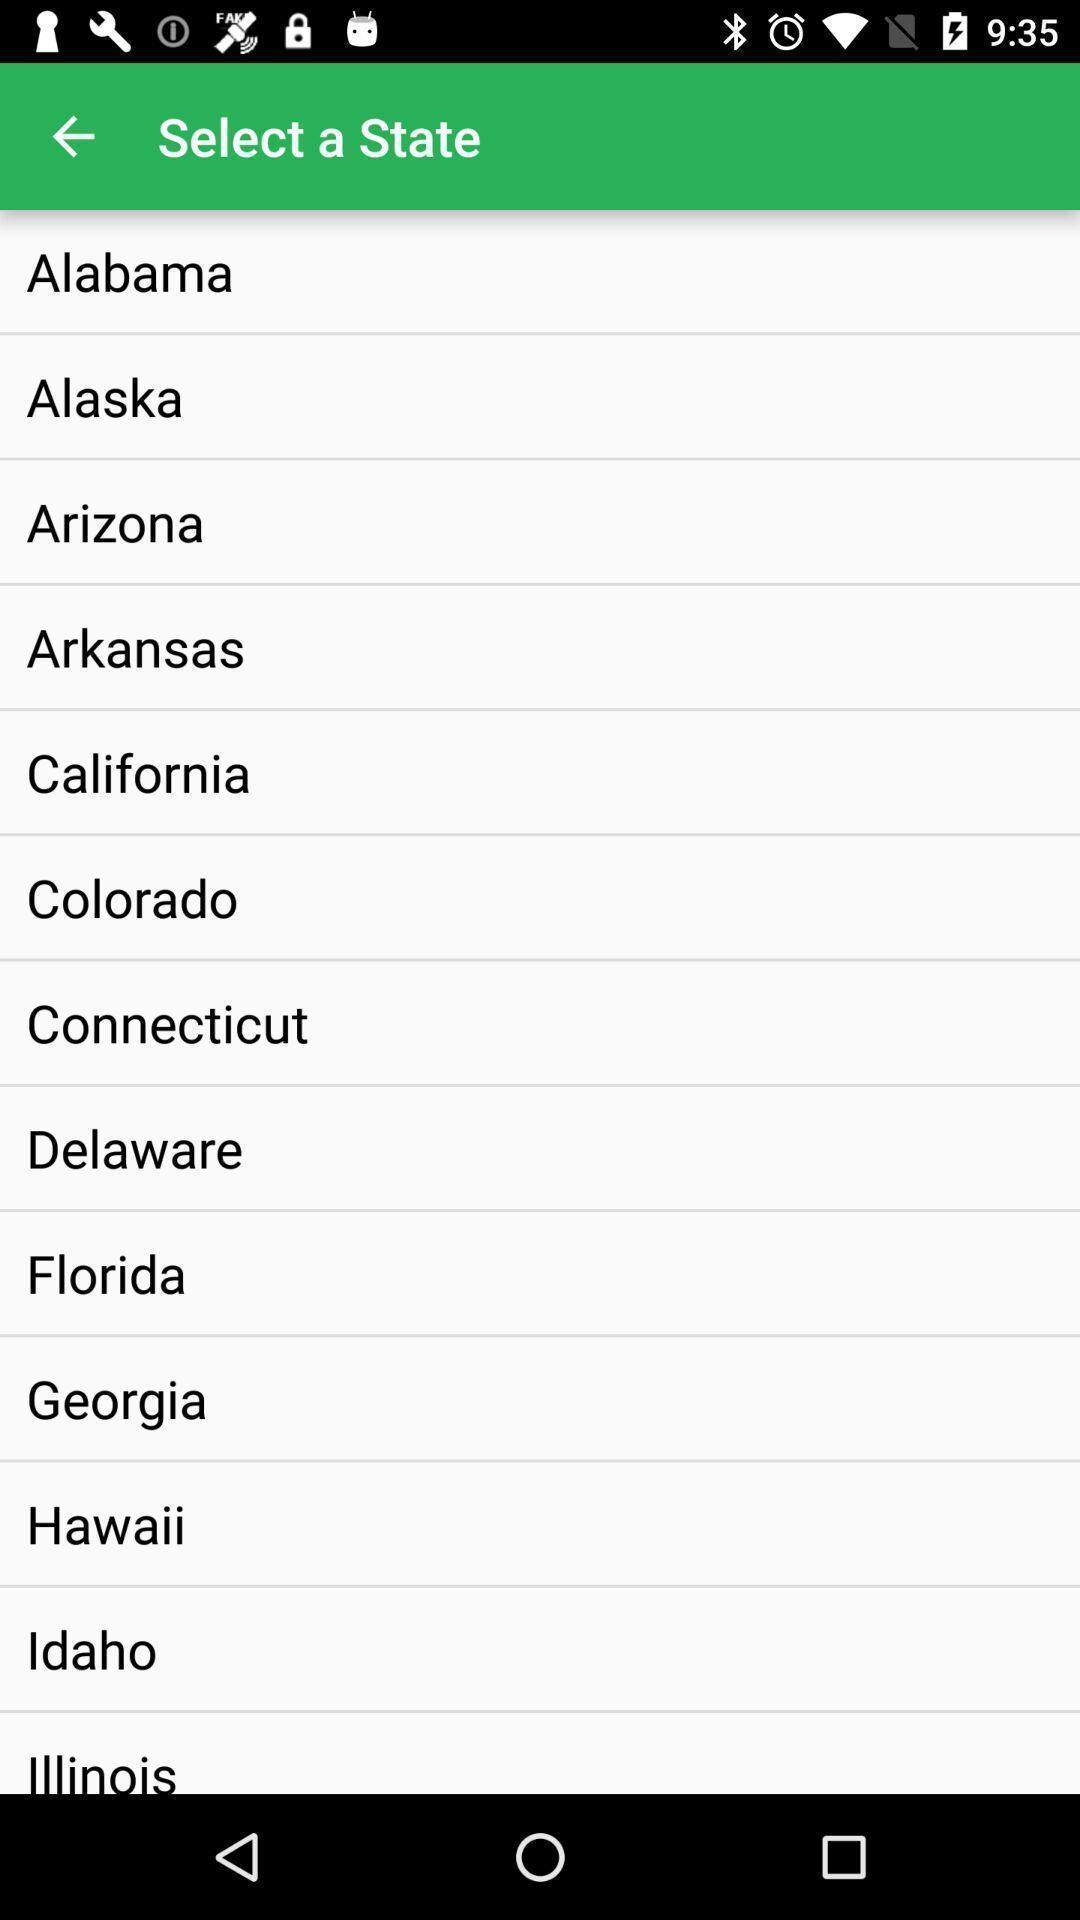Describe the key features of this screenshot. Page displaying to select a state. 